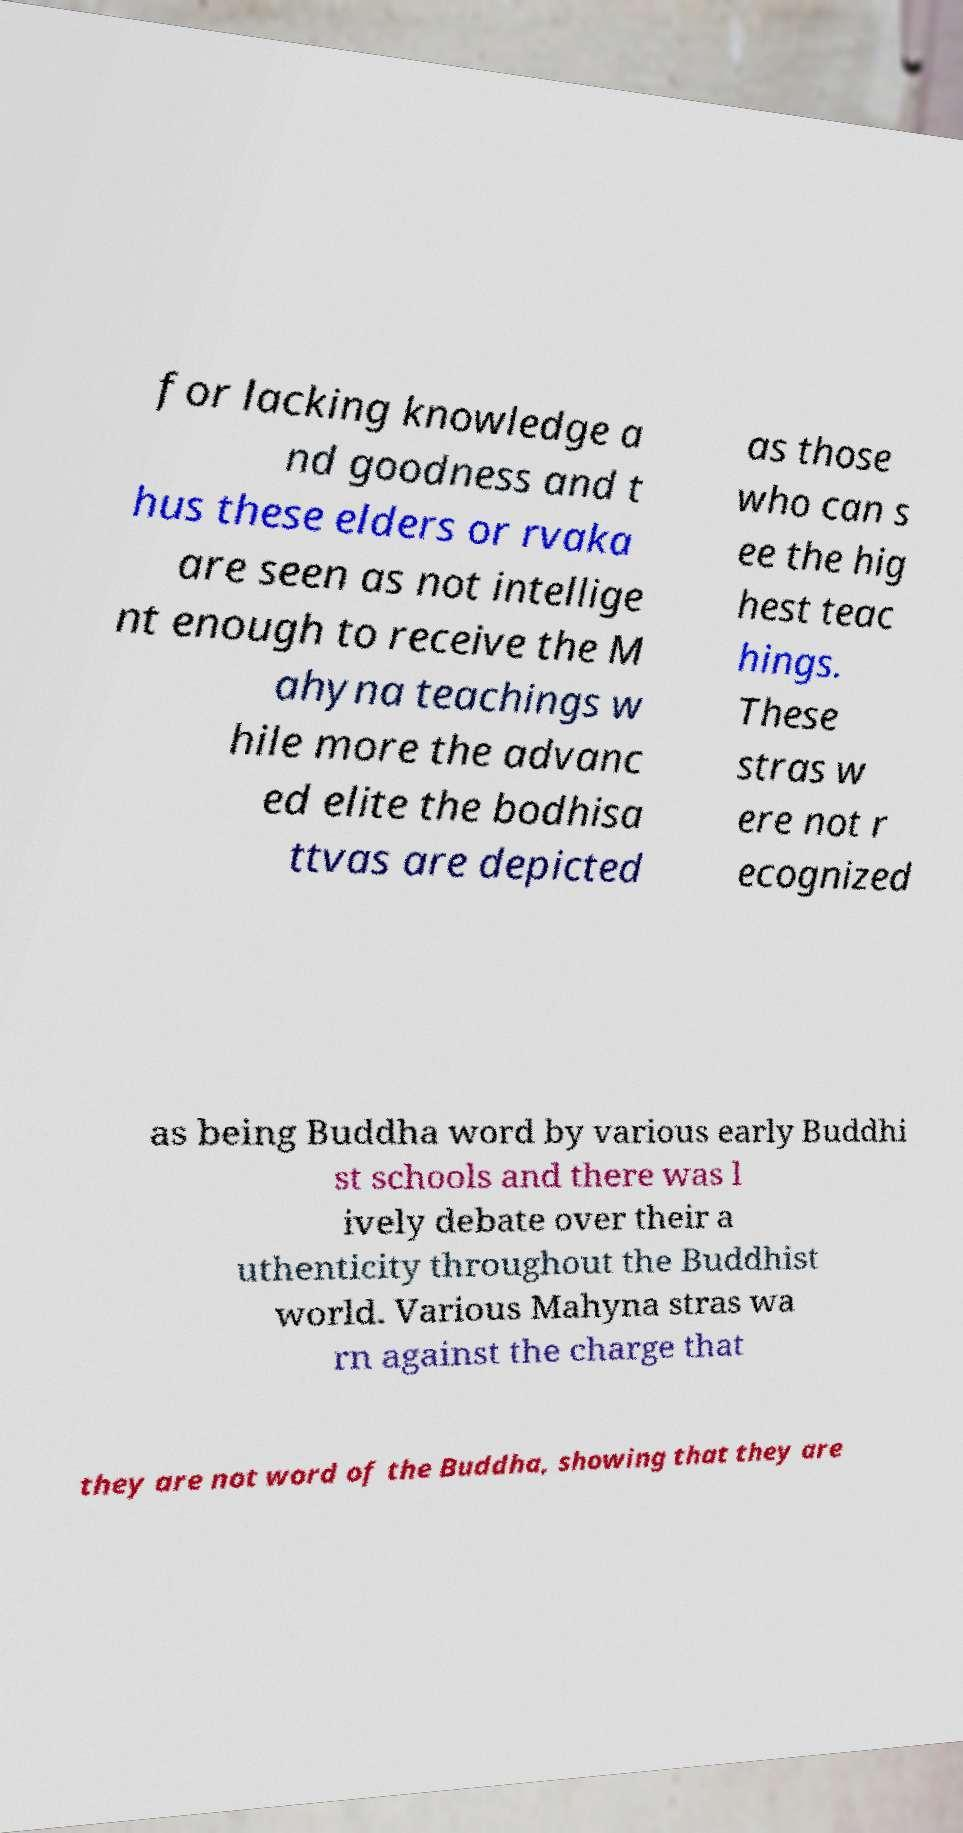Can you accurately transcribe the text from the provided image for me? for lacking knowledge a nd goodness and t hus these elders or rvaka are seen as not intellige nt enough to receive the M ahyna teachings w hile more the advanc ed elite the bodhisa ttvas are depicted as those who can s ee the hig hest teac hings. These stras w ere not r ecognized as being Buddha word by various early Buddhi st schools and there was l ively debate over their a uthenticity throughout the Buddhist world. Various Mahyna stras wa rn against the charge that they are not word of the Buddha, showing that they are 